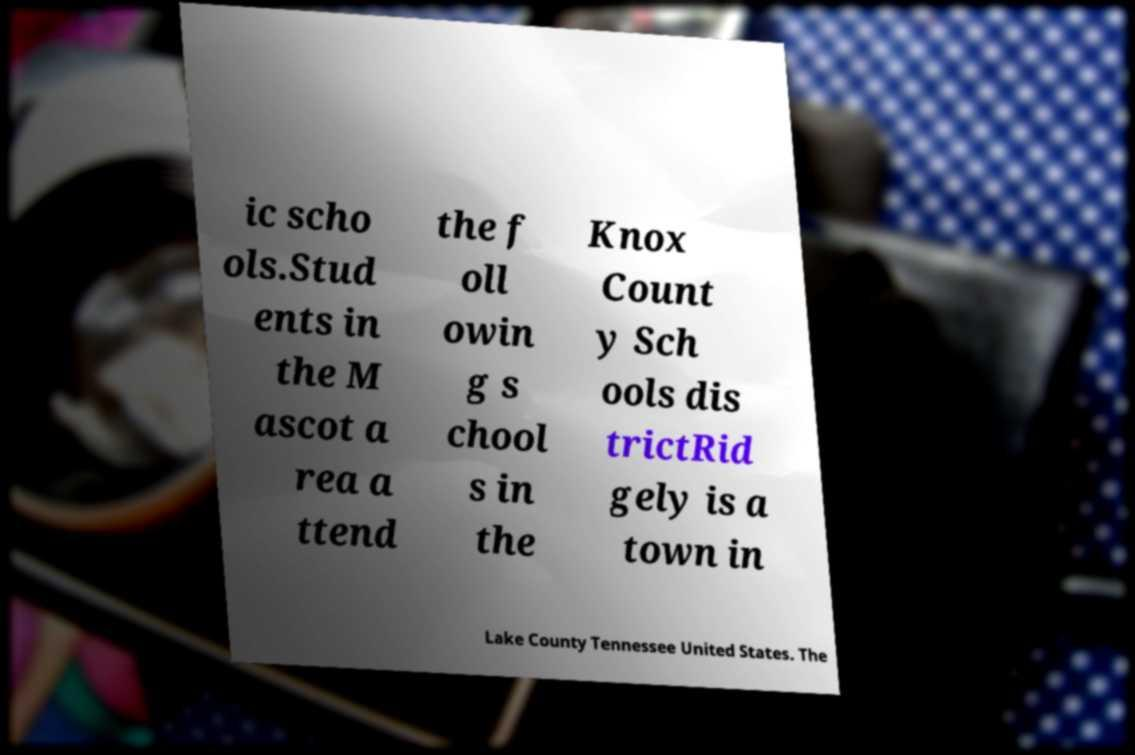Can you read and provide the text displayed in the image?This photo seems to have some interesting text. Can you extract and type it out for me? ic scho ols.Stud ents in the M ascot a rea a ttend the f oll owin g s chool s in the Knox Count y Sch ools dis trictRid gely is a town in Lake County Tennessee United States. The 